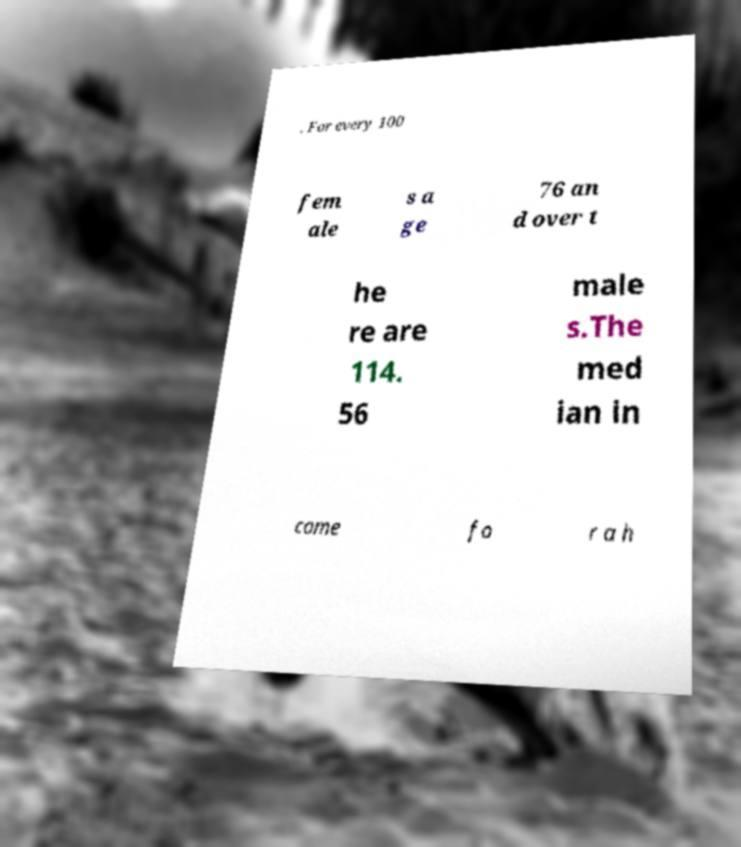Can you accurately transcribe the text from the provided image for me? . For every 100 fem ale s a ge 76 an d over t he re are 114. 56 male s.The med ian in come fo r a h 